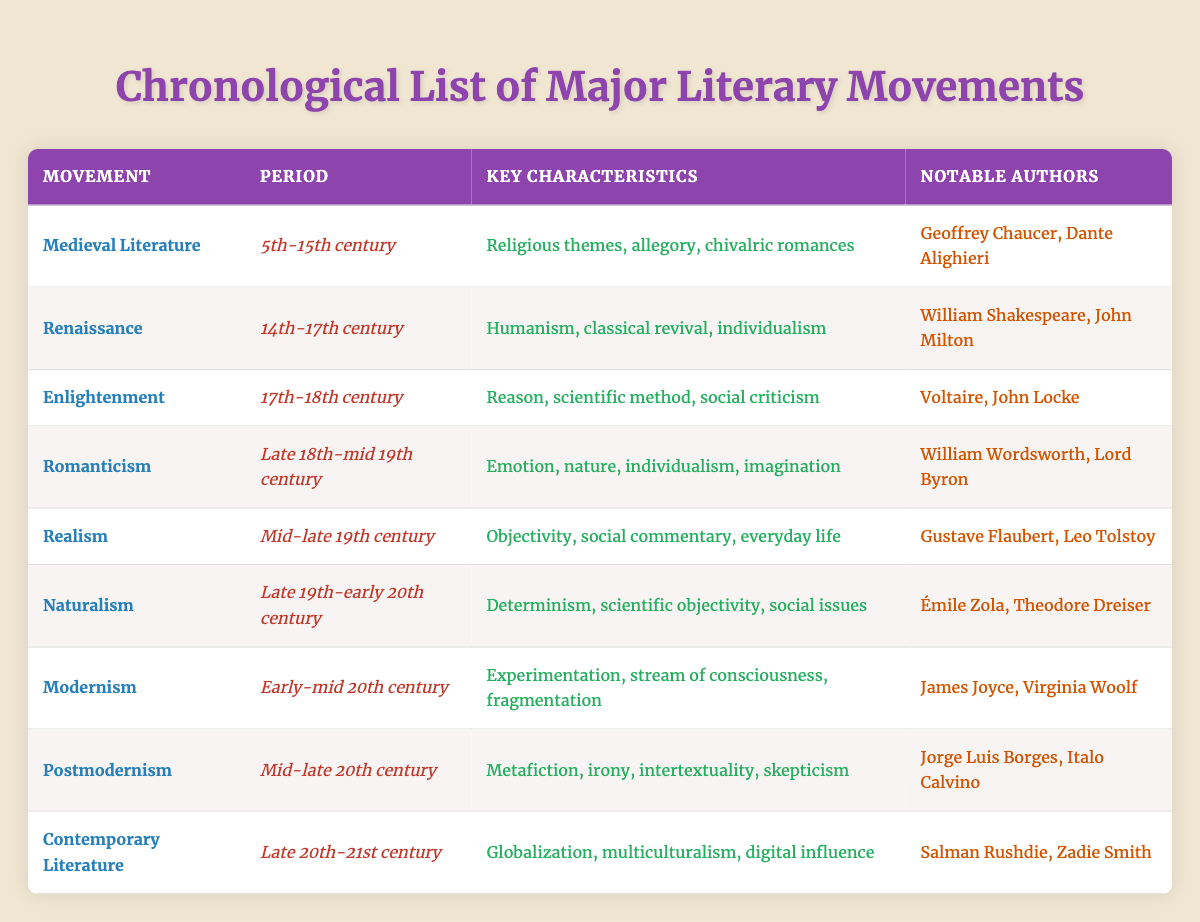What period does Romanticism cover? The table indicates that the Romanticism movement spans from the late 18th century to the mid-19th century.
Answer: Late 18th-mid 19th century Which authors are associated with the Enlightenment movement? Referring to the table, the notable authors listed for the Enlightenment are Voltaire and John Locke.
Answer: Voltaire, John Locke Does the Medieval Literature movement include any notable authors? The table shows that Medieval Literature has notable authors, specifically Geoffrey Chaucer and Dante Alighieri.
Answer: Yes What key characteristics define Modernism? According to the table, Modernism is characterized by experimentation, stream of consciousness, and fragmentation.
Answer: Experimentation, stream of consciousness, fragmentation List the movements that occurred in the 20th century. The table outlines three movements in the 20th century: Modernism (Early-mid 20th century), Postmodernism (Mid-late 20th century), and Contemporary Literature (Late 20th-21st century).
Answer: Modernism, Postmodernism, Contemporary Literature Which literary movement is characterized by religious themes? The table specifies that Medieval Literature is marked by religious themes, among other characteristics.
Answer: Medieval Literature How many movements listed in the table focus on social issues? The movements that focus on social issues, as indicated in the table, are Enlightenment, Realism, and Naturalism. That makes a total of three movements.
Answer: Three Is Individualism a characteristic of both Renaissance and Romanticism? The table confirms that Individualism is a characteristic of both the Renaissance and Romanticism movements.
Answer: Yes Which movement followed the Naturalism movement in chronological order? By examining the table, it is noticeable that Modernism follows Naturalism in the chronological list of movements.
Answer: Modernism What notable authors are associated with Postmodernism? The authors listed in the table for Postmodernism are Jorge Luis Borges and Italo Calvino.
Answer: Jorge Luis Borges, Italo Calvino Why might one argue that Contemporary Literature is influenced by digital media? The table states that Contemporary Literature includes globalization, multiculturalism, and digital influence, suggesting an intersection with digital media.
Answer: Digital influence 